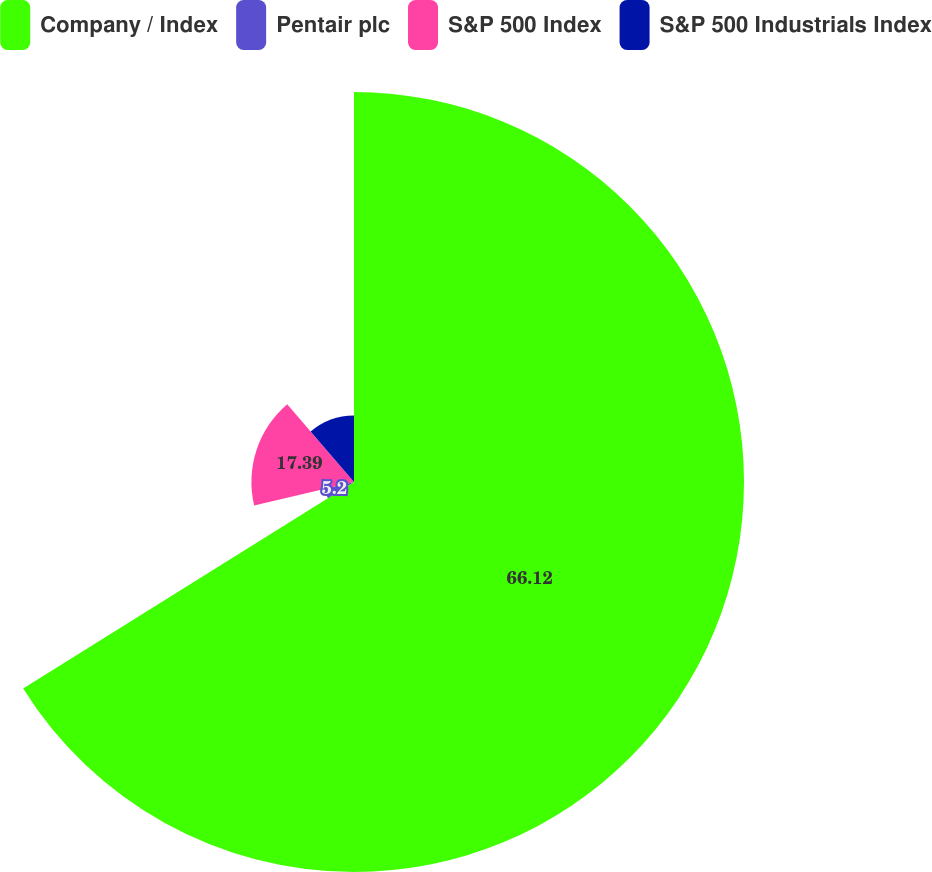Convert chart. <chart><loc_0><loc_0><loc_500><loc_500><pie_chart><fcel>Company / Index<fcel>Pentair plc<fcel>S&P 500 Index<fcel>S&P 500 Industrials Index<nl><fcel>66.12%<fcel>5.2%<fcel>17.39%<fcel>11.29%<nl></chart> 